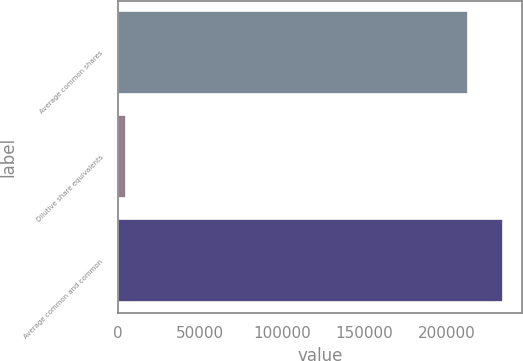<chart> <loc_0><loc_0><loc_500><loc_500><bar_chart><fcel>Average common shares<fcel>Dilutive share equivalents<fcel>Average common and common<nl><fcel>212702<fcel>4834<fcel>233972<nl></chart> 